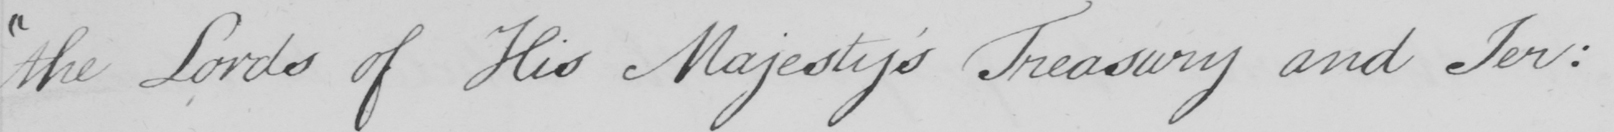What text is written in this handwritten line? the Lords of His Majesty ' s Treasury and Jer : 